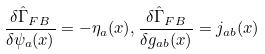Convert formula to latex. <formula><loc_0><loc_0><loc_500><loc_500>\frac { \delta \hat { \Gamma } _ { F B } } { \delta \psi _ { a } ( x ) } = - \eta _ { a } ( x ) , \frac { \delta \hat { \Gamma } _ { F B } } { \delta g _ { a b } ( x ) } = j _ { a b } ( x )</formula> 